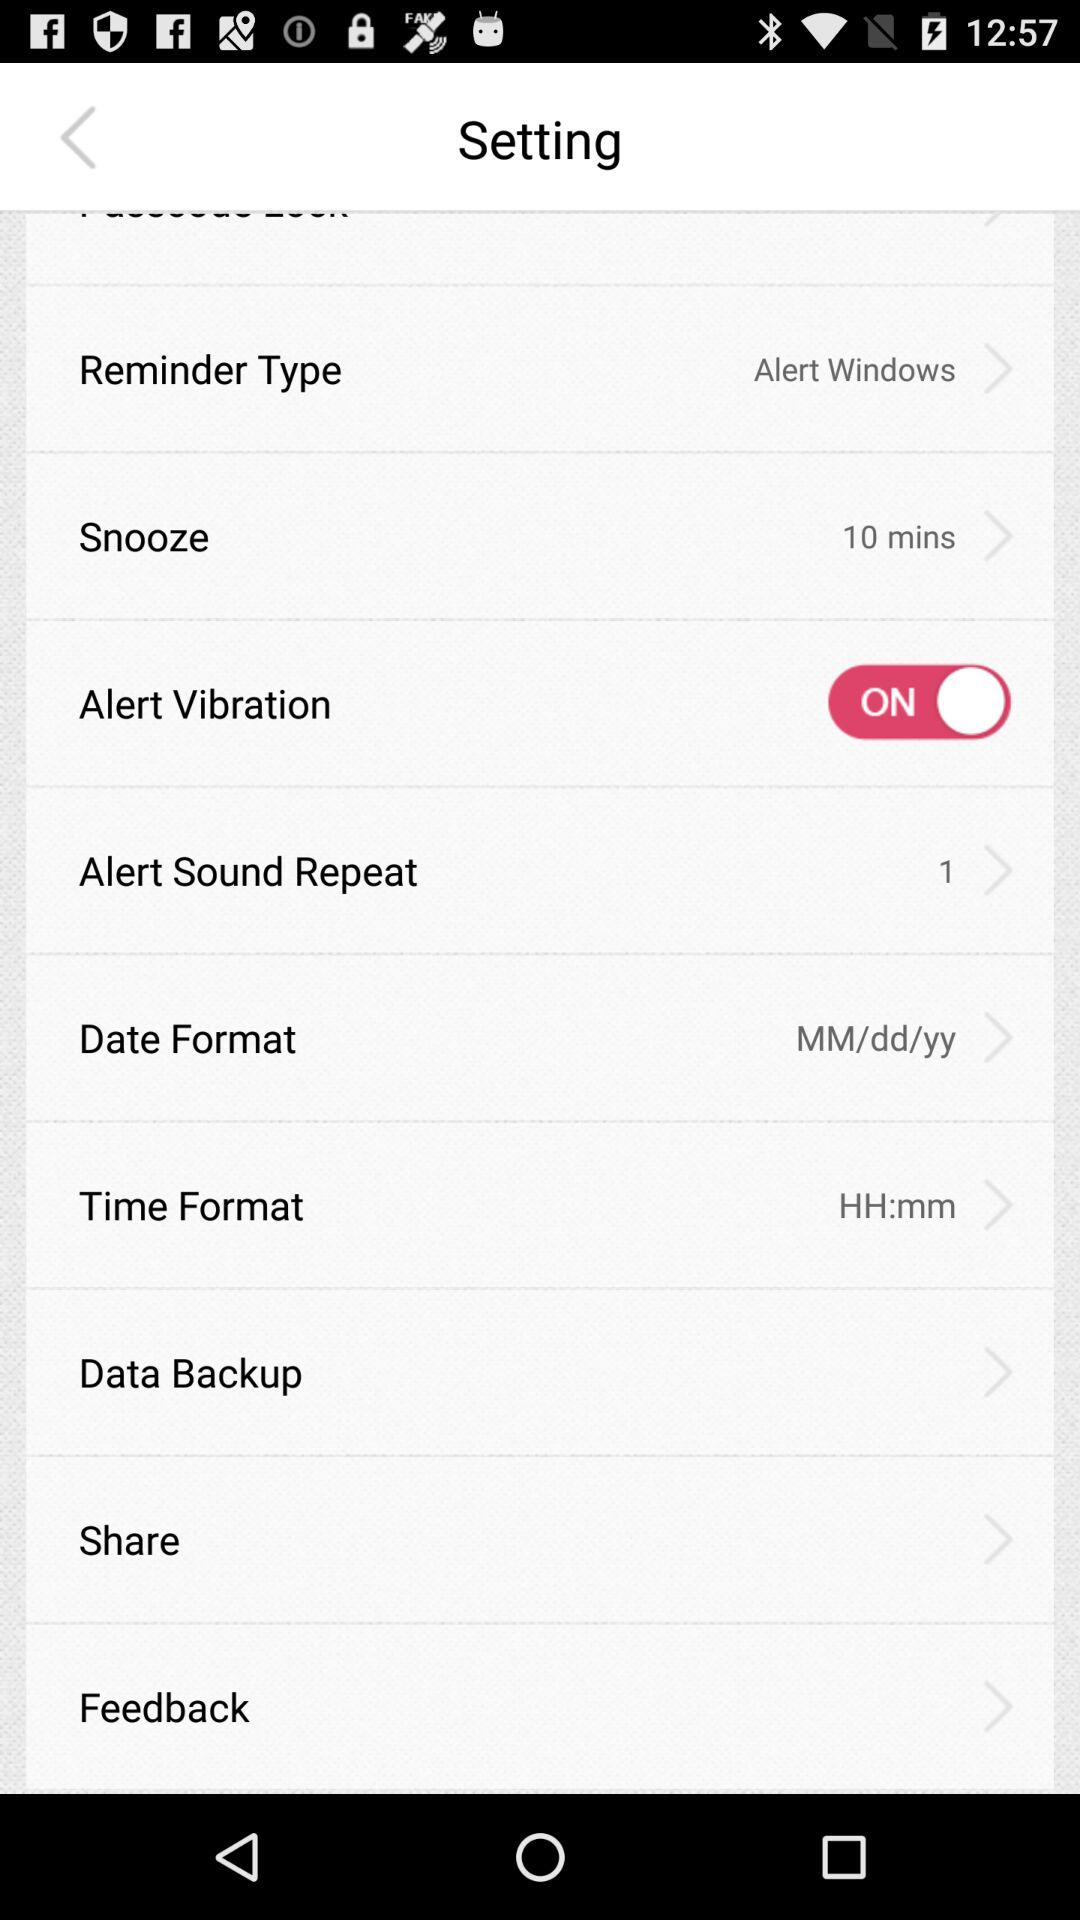What is the selected time format? The selected time format is "HH:mm". 